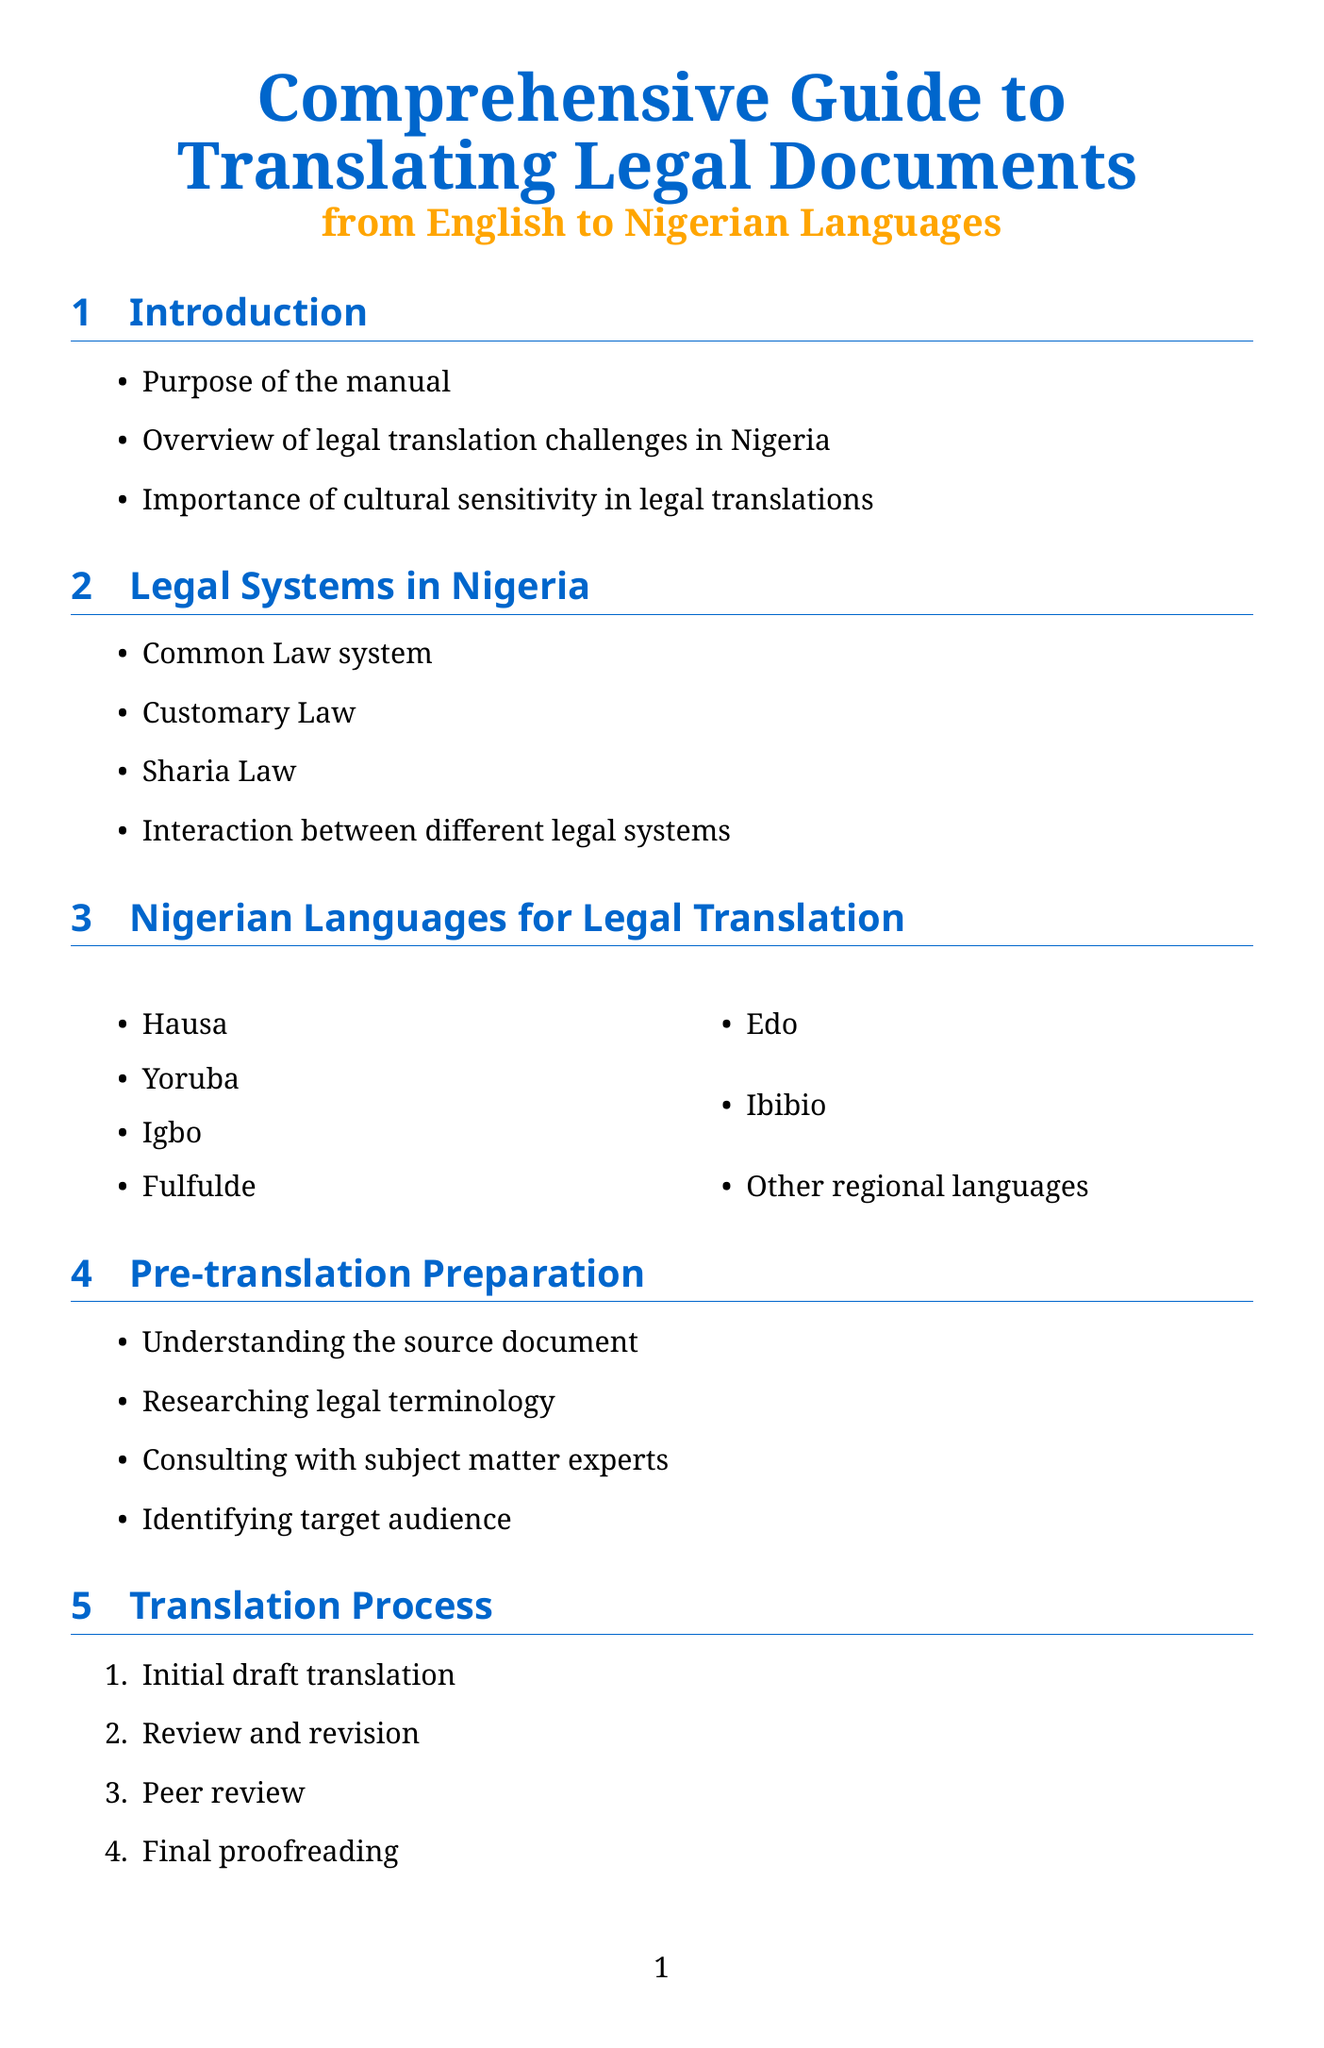What is the title of the manual? The title of the manual is provided at the top of the document.
Answer: Comprehensive Guide to Translating Legal Documents from English to Nigerian Languages How many Nigerian languages are listed for legal translation? The number of languages is enumerated in the relevant section.
Answer: Seven What is the first step in the translation process? The document outlines steps in the translation process, starting with the first step.
Answer: Initial draft translation What type of legal system is NOT mentioned in the document? The document lists legal systems in Nigeria, so any system not included would be the answer.
Answer: Civil Law Who is the author of the Nigerian Law Dictionary? The author is listed in the resources section of the manual.
Answer: Ese Malemi What is one of the challenges in translating legal terminology? Challenges are mentioned in the section dedicated to handling legal terminology.
Answer: Dealing with untranslatable terms Which section discusses cultural nuances? The section title addressing this topic is clearly labeled.
Answer: Cultural Nuances in Legal Translation What type of tools are mentioned for legal translation? The section details technological tools available for translation purposes.
Answer: Computer-Aided Translation (CAT) tools 